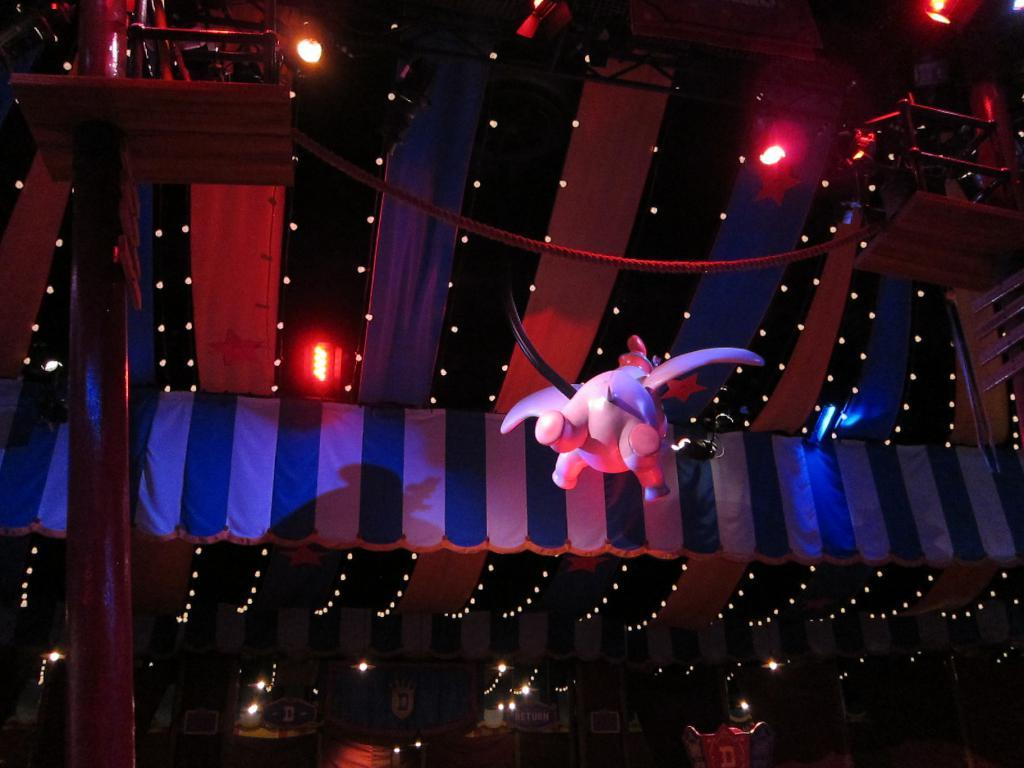What is located on the roof in the image? There are lights on the roof in the image. What other object can be seen in the air in the image? There is a toy visible in the air in the image. How many flowers are growing on the roof in the image? There are no flowers growing on the roof in the image. What type of invention is being demonstrated in the image? There is no invention being demonstrated in the image; it only features lights on the roof and a toy in the air. 